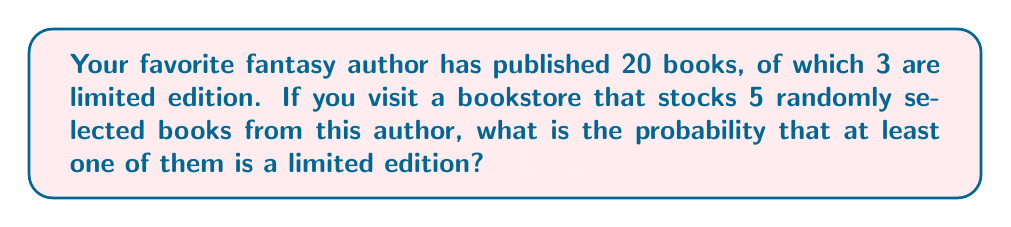Provide a solution to this math problem. Let's approach this step-by-step:

1) First, we'll calculate the probability of not getting any limited edition books. This is easier than calculating the probability of getting at least one directly.

2) The probability of selecting a non-limited edition book is:

   $\frac{17}{20}$ (17 non-limited edition books out of 20 total)

3) We need all 5 selections to be non-limited edition. The probability of this happening is:

   $(\frac{17}{20})^5$

4) Now, the probability of getting at least one limited edition book is the opposite of getting no limited edition books. So we subtract our result from 1:

   $1 - (\frac{17}{20})^5$

5) Let's calculate this:

   $1 - (\frac{17}{20})^5 = 1 - (0.85)^5 = 1 - 0.4437 = 0.5563$

6) Therefore, the probability of finding at least one limited edition book is approximately 0.5563 or 55.63%.
Answer: $1 - (\frac{17}{20})^5 \approx 0.5563$ 